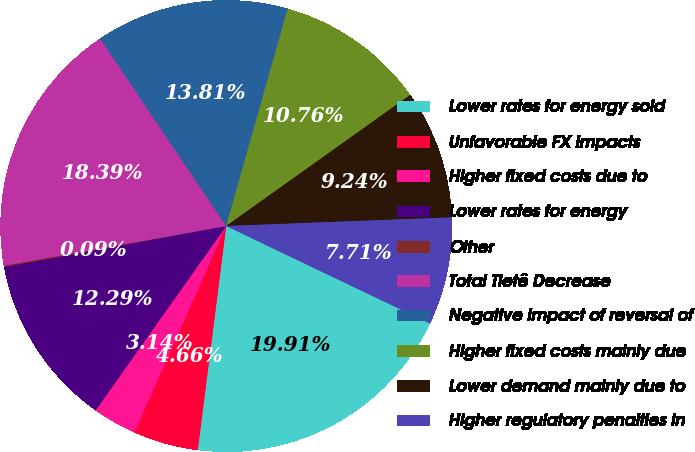<chart> <loc_0><loc_0><loc_500><loc_500><pie_chart><fcel>Lower rates for energy sold<fcel>Unfavorable FX impacts<fcel>Higher fixed costs due to<fcel>Lower rates for energy<fcel>Other<fcel>Total Tietê Decrease<fcel>Negative impact of reversal of<fcel>Higher fixed costs mainly due<fcel>Lower demand mainly due to<fcel>Higher regulatory penalties in<nl><fcel>19.91%<fcel>4.66%<fcel>3.14%<fcel>12.29%<fcel>0.09%<fcel>18.39%<fcel>13.81%<fcel>10.76%<fcel>9.24%<fcel>7.71%<nl></chart> 